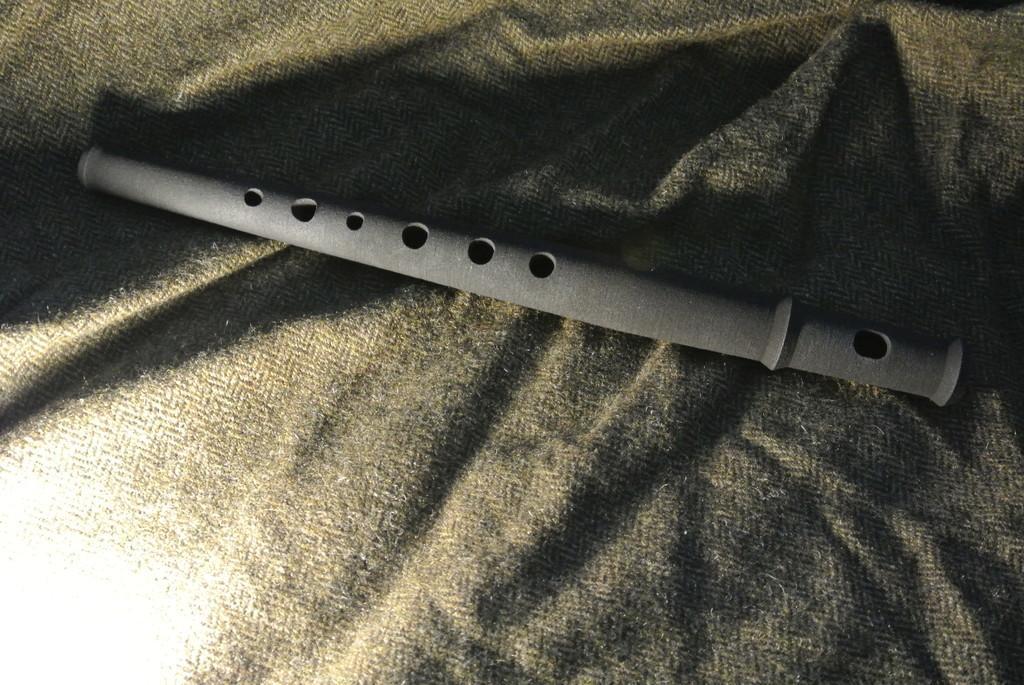Describe this image in one or two sentences. There is a flute on a cloth. 